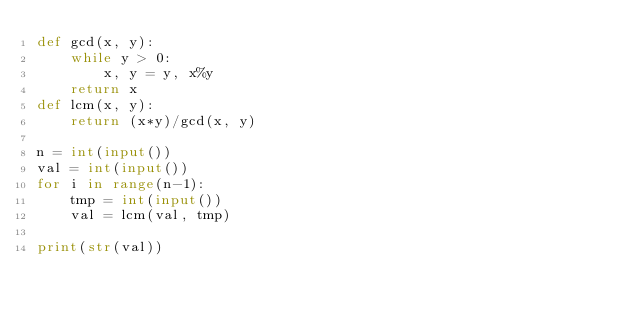Convert code to text. <code><loc_0><loc_0><loc_500><loc_500><_Python_>def gcd(x, y):
    while y > 0:
        x, y = y, x%y
    return x
def lcm(x, y):
    return (x*y)/gcd(x, y)
 
n = int(input())
val = int(input())
for i in range(n-1):
    tmp = int(input())
    val = lcm(val, tmp)
 
print(str(val))</code> 